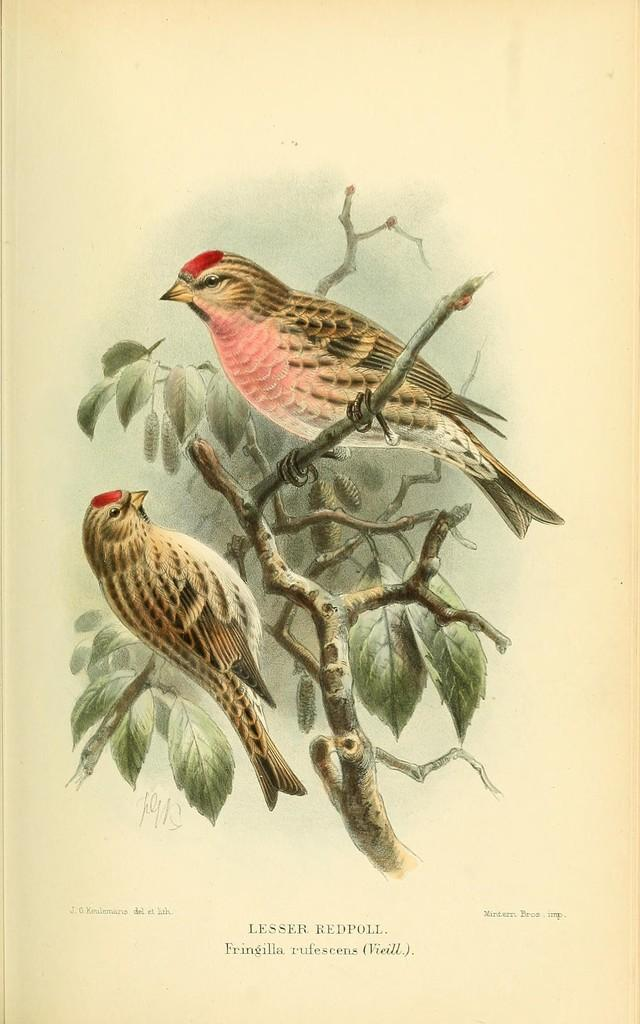What subjects are depicted in the paintings in the image? There is a painting of birds and a painting of a tree in the image. What material are the paintings on? The paintings are on paper. Is there any text present in the image? Yes, there is text at the bottom of the image. What type of silverware is being used to eat the bun in the image? There is no silverware or bun present in the image; it features paintings of birds and a tree on paper with text at the bottom. 